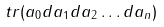<formula> <loc_0><loc_0><loc_500><loc_500>\ t r ( a _ { 0 } d a _ { 1 } d a _ { 2 } \dots d a _ { n } )</formula> 